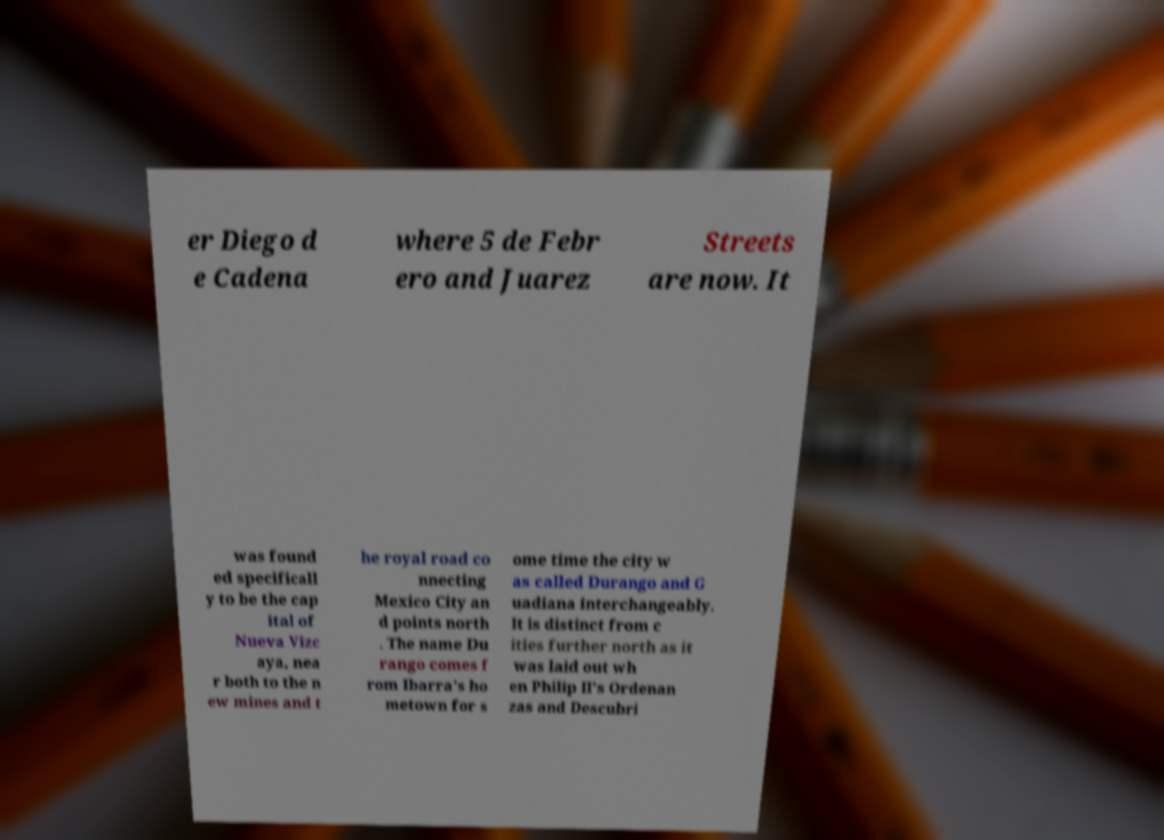Please identify and transcribe the text found in this image. er Diego d e Cadena where 5 de Febr ero and Juarez Streets are now. It was found ed specificall y to be the cap ital of Nueva Vizc aya, nea r both to the n ew mines and t he royal road co nnecting Mexico City an d points north . The name Du rango comes f rom Ibarra's ho metown for s ome time the city w as called Durango and G uadiana interchangeably. It is distinct from c ities further north as it was laid out wh en Philip II's Ordenan zas and Descubri 